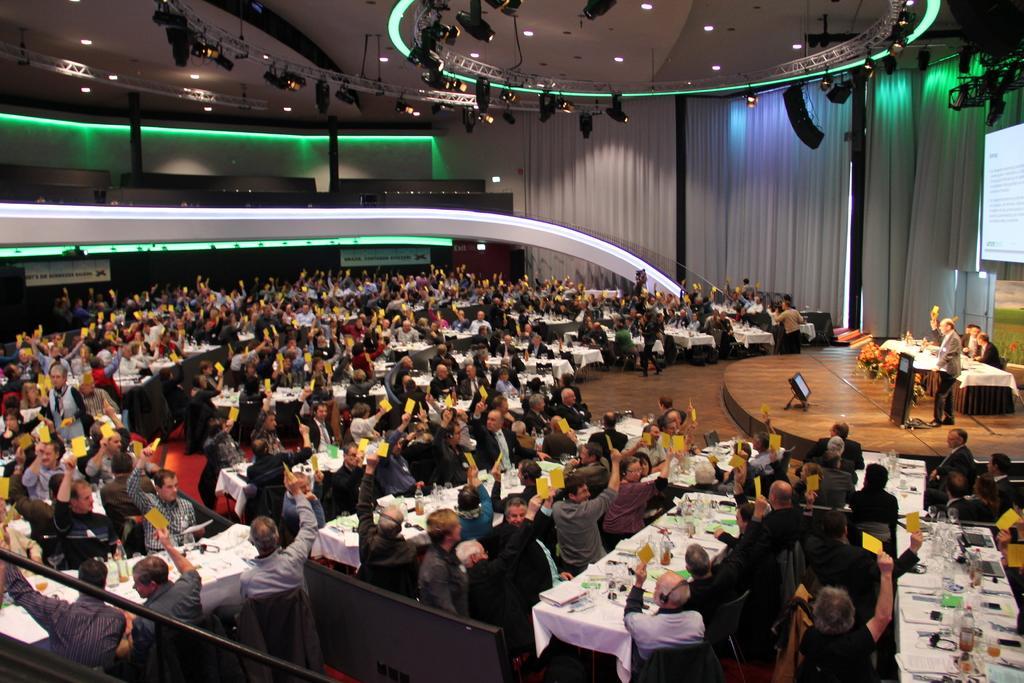Please provide a concise description of this image. This picture describes about group of people, few are sitting on the chairs and few are standing, in front of them we can see bottles, glasses, papers and other things on the tables, in the background we can find few lights, hoardings, curtains and a projector screen. 